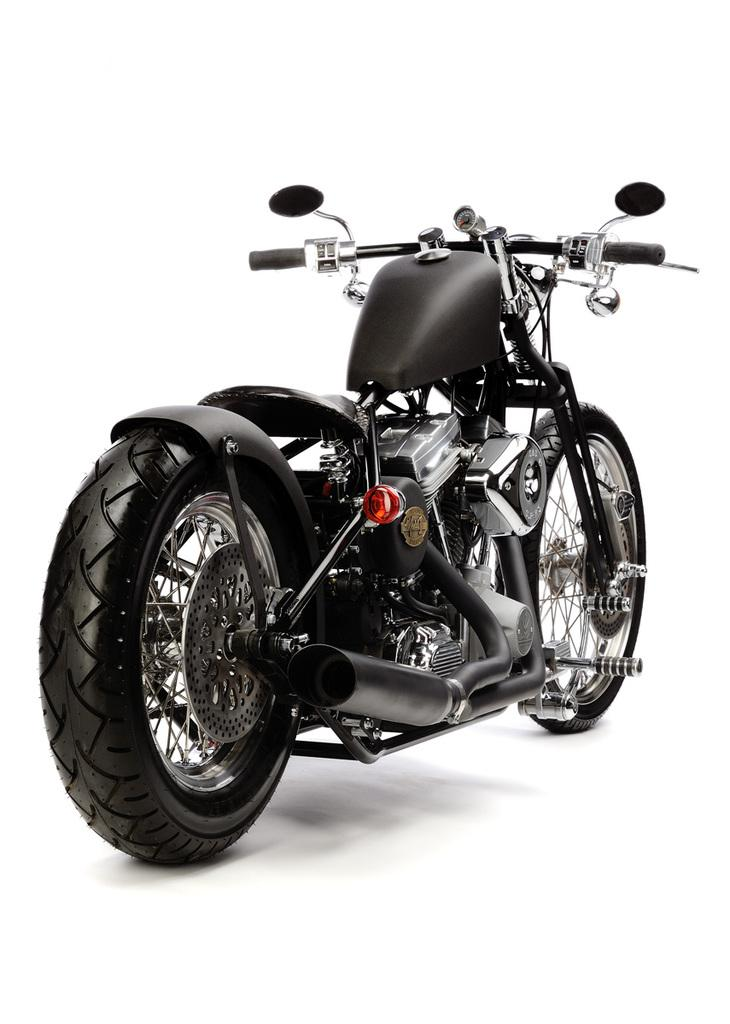What is the main subject in the foreground of the image? There is a motorbike in the foreground of the image. What color is the background of the image? The background of the image is white. What type of leather material is visible on the motorbike in the image? There is no specific mention of leather material on the motorbike in the provided facts. What time of day is it in the image, given the presence of the morning topic? The provided facts do not mention the time of day or any indication of morning. What type of town or city is visible in the background of the image? The provided facts do not mention any town or city in the background of the image. 